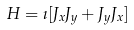Convert formula to latex. <formula><loc_0><loc_0><loc_500><loc_500>H = \zeta [ J _ { x } J _ { y } + J _ { y } J _ { x } ]</formula> 